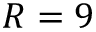<formula> <loc_0><loc_0><loc_500><loc_500>R = 9</formula> 